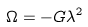Convert formula to latex. <formula><loc_0><loc_0><loc_500><loc_500>\Omega = - G \lambda ^ { 2 }</formula> 